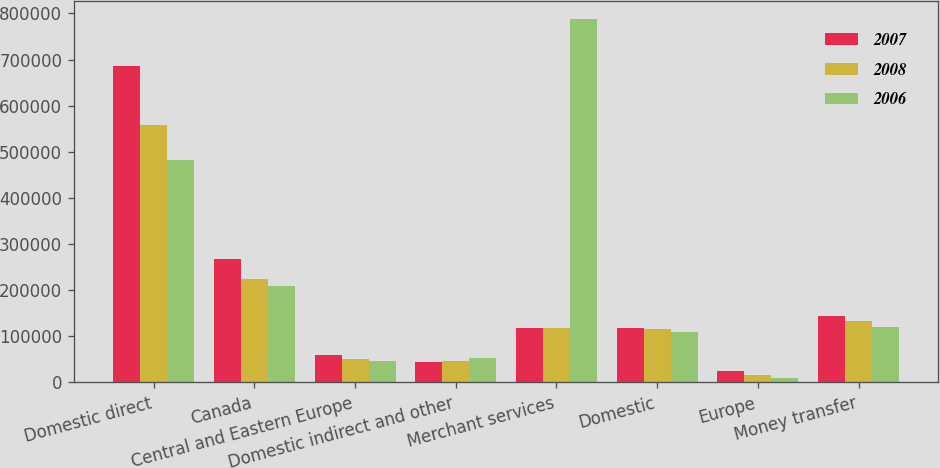<chart> <loc_0><loc_0><loc_500><loc_500><stacked_bar_chart><ecel><fcel>Domestic direct<fcel>Canada<fcel>Central and Eastern Europe<fcel>Domestic indirect and other<fcel>Merchant services<fcel>Domestic<fcel>Europe<fcel>Money transfer<nl><fcel>2007<fcel>687065<fcel>267249<fcel>59778<fcel>44150<fcel>117218<fcel>119019<fcel>24601<fcel>143620<nl><fcel>2008<fcel>558026<fcel>224570<fcel>51224<fcel>46873<fcel>117218<fcel>115416<fcel>16965<fcel>132381<nl><fcel>2006<fcel>481273<fcel>208126<fcel>47114<fcel>51987<fcel>788500<fcel>109067<fcel>10489<fcel>119556<nl></chart> 